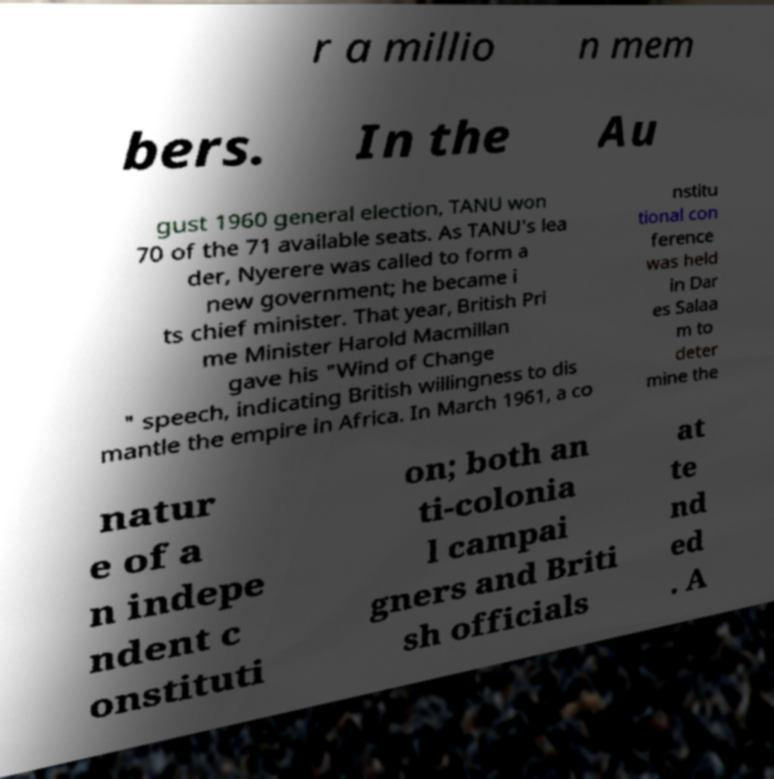Could you assist in decoding the text presented in this image and type it out clearly? r a millio n mem bers. In the Au gust 1960 general election, TANU won 70 of the 71 available seats. As TANU's lea der, Nyerere was called to form a new government; he became i ts chief minister. That year, British Pri me Minister Harold Macmillan gave his "Wind of Change " speech, indicating British willingness to dis mantle the empire in Africa. In March 1961, a co nstitu tional con ference was held in Dar es Salaa m to deter mine the natur e of a n indepe ndent c onstituti on; both an ti-colonia l campai gners and Briti sh officials at te nd ed . A 